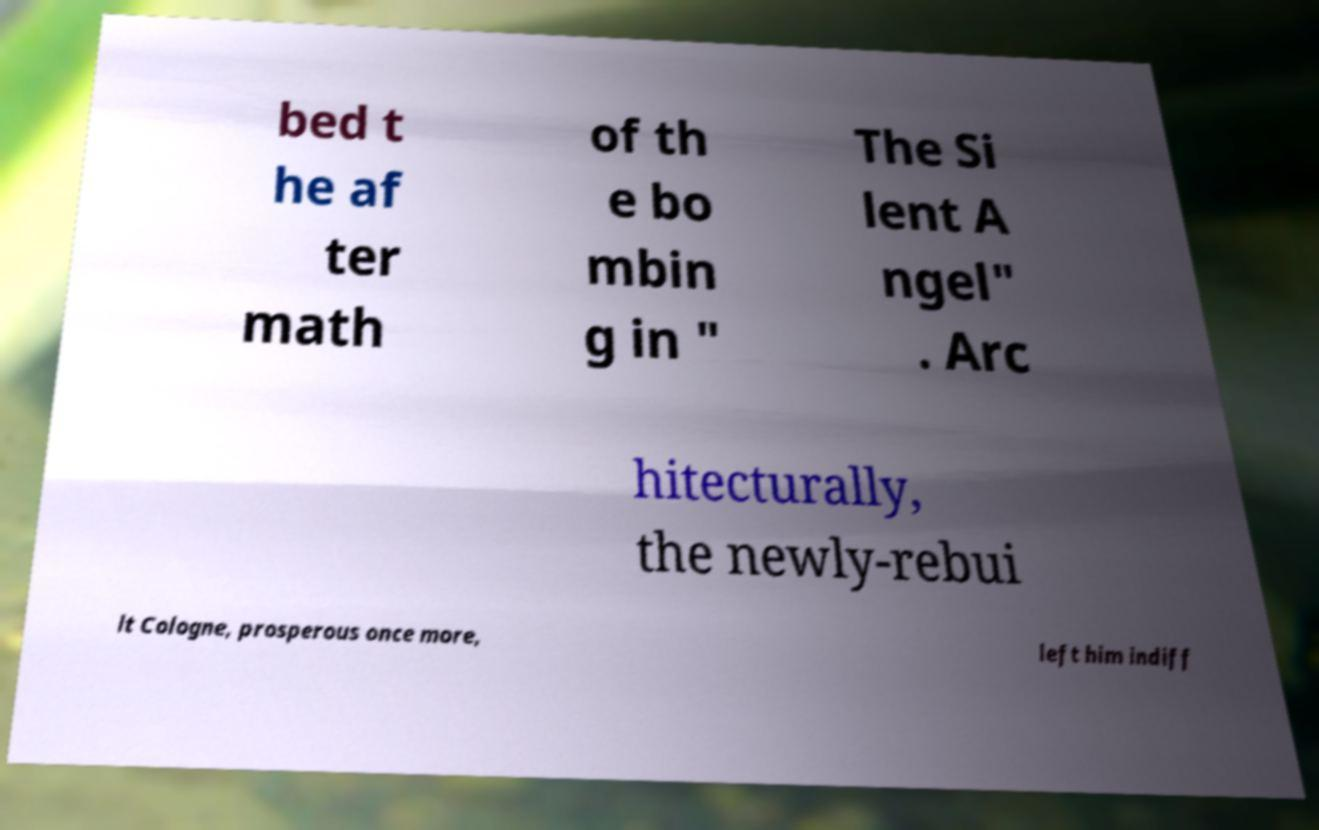I need the written content from this picture converted into text. Can you do that? bed t he af ter math of th e bo mbin g in " The Si lent A ngel" . Arc hitecturally, the newly-rebui lt Cologne, prosperous once more, left him indiff 